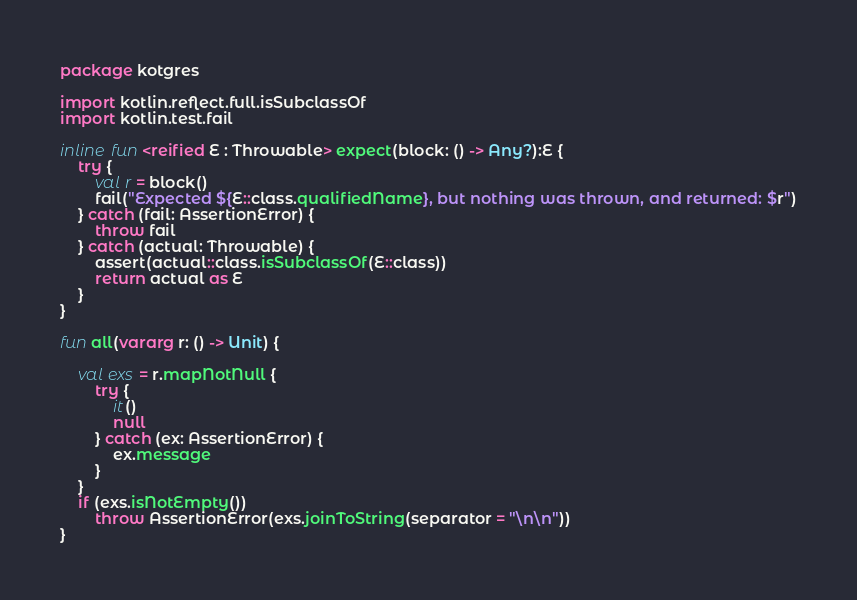<code> <loc_0><loc_0><loc_500><loc_500><_Kotlin_>package kotgres

import kotlin.reflect.full.isSubclassOf
import kotlin.test.fail

inline fun <reified E : Throwable> expect(block: () -> Any?):E {
    try {
        val r = block()
        fail("Expected ${E::class.qualifiedName}, but nothing was thrown, and returned: $r")
    } catch (fail: AssertionError) {
        throw fail
    } catch (actual: Throwable) {
        assert(actual::class.isSubclassOf(E::class))
        return actual as E
    }
}

fun all(vararg r: () -> Unit) {

    val exs = r.mapNotNull {
        try {
            it()
            null
        } catch (ex: AssertionError) {
            ex.message
        }
    }
    if (exs.isNotEmpty())
        throw AssertionError(exs.joinToString(separator = "\n\n"))
}</code> 